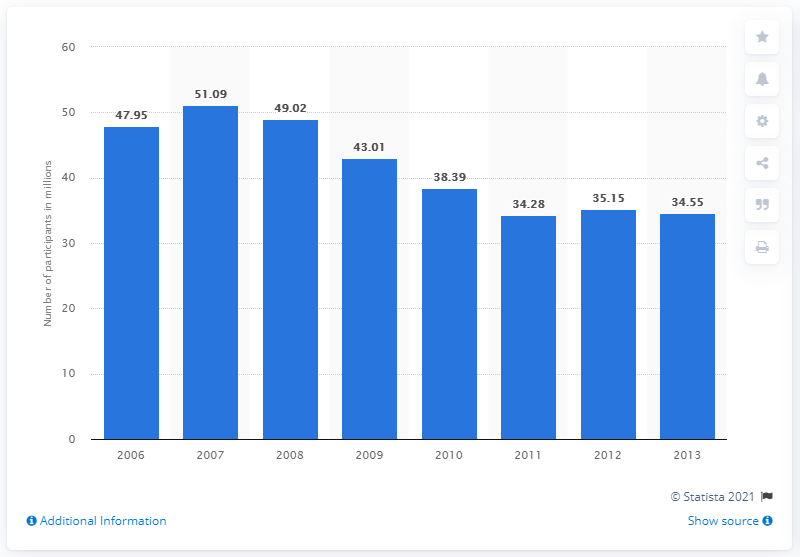Identify some key points in this picture. In 2013, the total number of participants in billiards/pool was 34.55. 